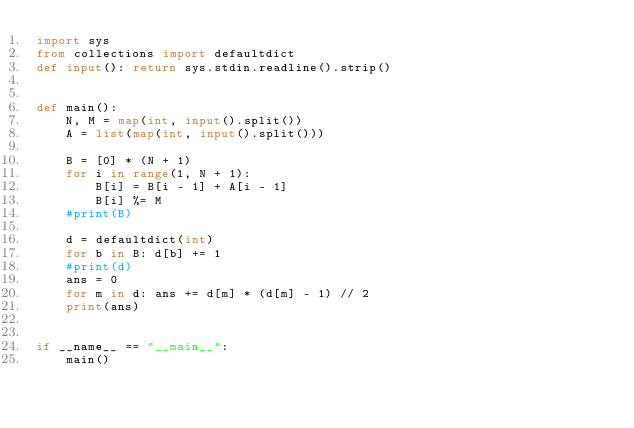Convert code to text. <code><loc_0><loc_0><loc_500><loc_500><_Python_>import sys
from collections import defaultdict
def input(): return sys.stdin.readline().strip()


def main():
    N, M = map(int, input().split())
    A = list(map(int, input().split()))

    B = [0] * (N + 1)
    for i in range(1, N + 1):
        B[i] = B[i - 1] + A[i - 1]
        B[i] %= M
    #print(B)
    
    d = defaultdict(int)
    for b in B: d[b] += 1
    #print(d)
    ans = 0
    for m in d: ans += d[m] * (d[m] - 1) // 2
    print(ans)
    

if __name__ == "__main__":
    main()
</code> 